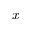Convert formula to latex. <formula><loc_0><loc_0><loc_500><loc_500>x</formula> 